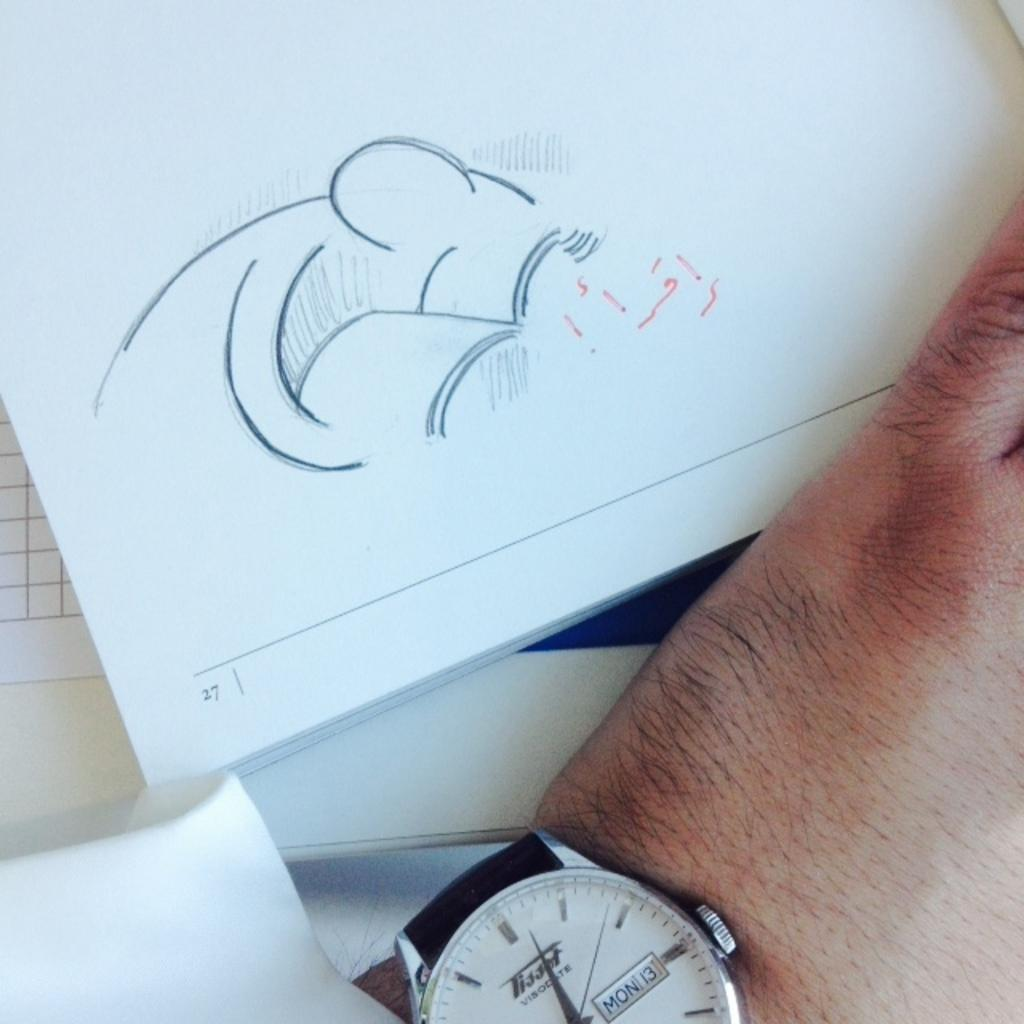Provide a one-sentence caption for the provided image. A person with a sketch on page 27 and showing part of the hand and watch with date Mon 13. 